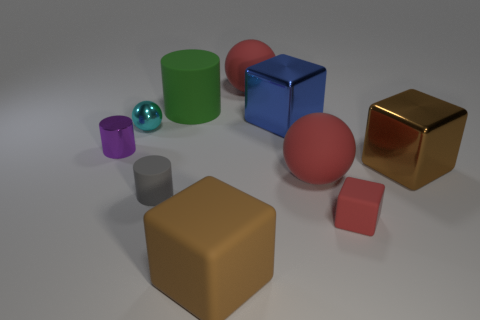There is a purple thing that is the same size as the cyan shiny object; what material is it?
Offer a terse response. Metal. There is a tiny gray object that is the same shape as the large green thing; what is its material?
Give a very brief answer. Rubber. Is the number of blue metal things that are in front of the small cyan shiny object greater than the number of red balls behind the brown shiny block?
Offer a terse response. No. There is a tiny gray object that is the same material as the red block; what is its shape?
Offer a terse response. Cylinder. Are there more small things that are on the left side of the large brown rubber thing than cyan matte objects?
Offer a terse response. Yes. How many large matte things have the same color as the small metallic ball?
Offer a terse response. 0. What number of other objects are the same color as the shiny ball?
Your response must be concise. 0. Are there more green matte things than big brown cylinders?
Your response must be concise. Yes. What is the material of the large green object?
Ensure brevity in your answer.  Rubber. Is the size of the brown block behind the red block the same as the small red matte block?
Make the answer very short. No. 